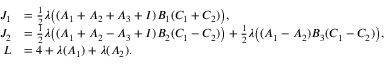<formula> <loc_0><loc_0><loc_500><loc_500>\begin{array} { r l } { J _ { 1 } } & { = \frac { 1 } { 2 } \lambda \left ( ( A _ { 1 } + A _ { 2 } + A _ { 3 } + I ) B _ { 1 } ( C _ { 1 } + C _ { 2 } ) \right ) , } \\ { J _ { 2 } } & { = \frac { 1 } { 2 } \lambda \left ( ( A _ { 1 } + A _ { 2 } - A _ { 3 } + I ) B _ { 2 } ( C _ { 1 } - C _ { 2 } ) \right ) + \frac { 1 } { 2 } \lambda \left ( ( A _ { 1 } - A _ { 2 } ) B _ { 3 } ( C _ { 1 } - C _ { 2 } ) \right ) , } \\ { L } & { = 4 + \lambda ( A _ { 1 } ) + \lambda ( A _ { 2 } ) . } \end{array}</formula> 